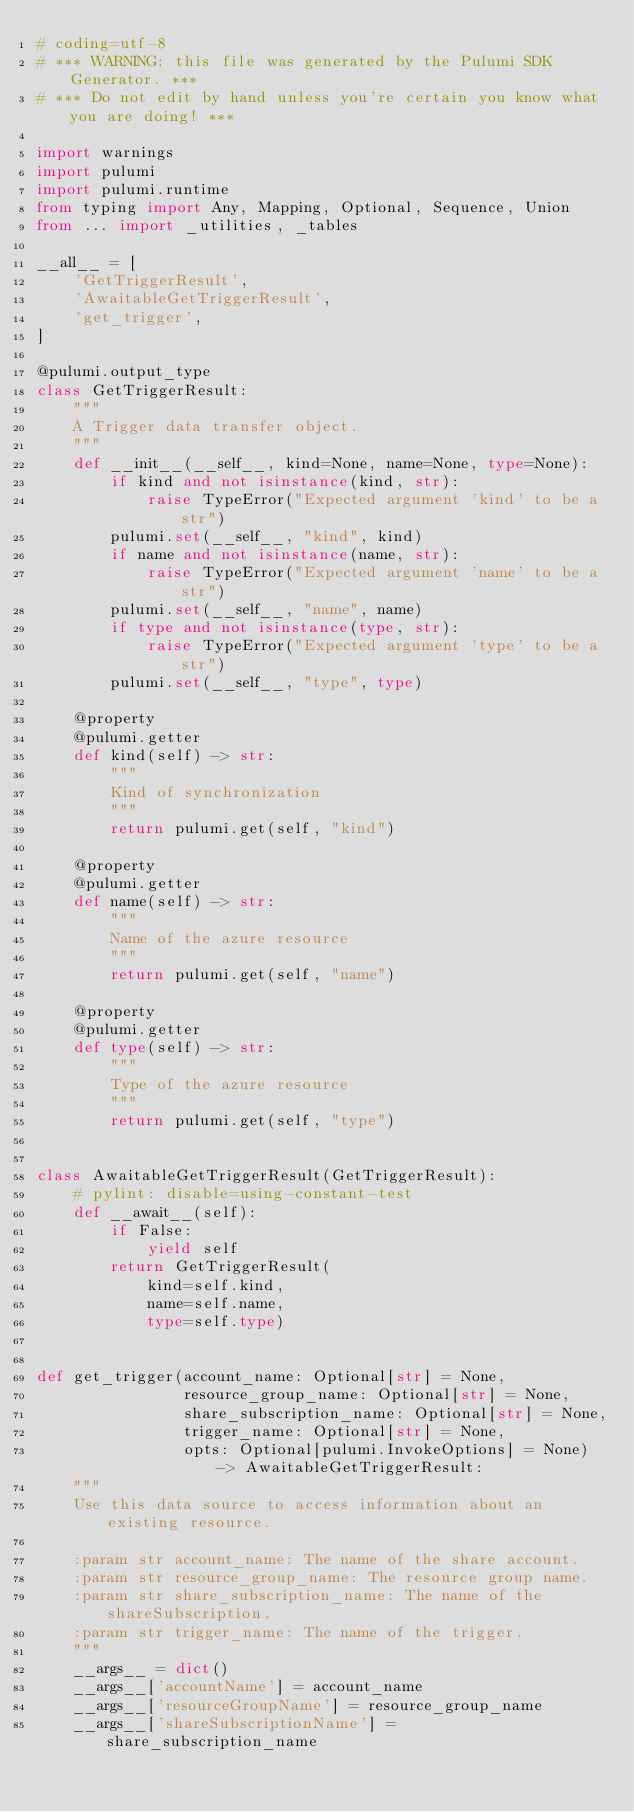<code> <loc_0><loc_0><loc_500><loc_500><_Python_># coding=utf-8
# *** WARNING: this file was generated by the Pulumi SDK Generator. ***
# *** Do not edit by hand unless you're certain you know what you are doing! ***

import warnings
import pulumi
import pulumi.runtime
from typing import Any, Mapping, Optional, Sequence, Union
from ... import _utilities, _tables

__all__ = [
    'GetTriggerResult',
    'AwaitableGetTriggerResult',
    'get_trigger',
]

@pulumi.output_type
class GetTriggerResult:
    """
    A Trigger data transfer object.
    """
    def __init__(__self__, kind=None, name=None, type=None):
        if kind and not isinstance(kind, str):
            raise TypeError("Expected argument 'kind' to be a str")
        pulumi.set(__self__, "kind", kind)
        if name and not isinstance(name, str):
            raise TypeError("Expected argument 'name' to be a str")
        pulumi.set(__self__, "name", name)
        if type and not isinstance(type, str):
            raise TypeError("Expected argument 'type' to be a str")
        pulumi.set(__self__, "type", type)

    @property
    @pulumi.getter
    def kind(self) -> str:
        """
        Kind of synchronization
        """
        return pulumi.get(self, "kind")

    @property
    @pulumi.getter
    def name(self) -> str:
        """
        Name of the azure resource
        """
        return pulumi.get(self, "name")

    @property
    @pulumi.getter
    def type(self) -> str:
        """
        Type of the azure resource
        """
        return pulumi.get(self, "type")


class AwaitableGetTriggerResult(GetTriggerResult):
    # pylint: disable=using-constant-test
    def __await__(self):
        if False:
            yield self
        return GetTriggerResult(
            kind=self.kind,
            name=self.name,
            type=self.type)


def get_trigger(account_name: Optional[str] = None,
                resource_group_name: Optional[str] = None,
                share_subscription_name: Optional[str] = None,
                trigger_name: Optional[str] = None,
                opts: Optional[pulumi.InvokeOptions] = None) -> AwaitableGetTriggerResult:
    """
    Use this data source to access information about an existing resource.

    :param str account_name: The name of the share account.
    :param str resource_group_name: The resource group name.
    :param str share_subscription_name: The name of the shareSubscription.
    :param str trigger_name: The name of the trigger.
    """
    __args__ = dict()
    __args__['accountName'] = account_name
    __args__['resourceGroupName'] = resource_group_name
    __args__['shareSubscriptionName'] = share_subscription_name</code> 